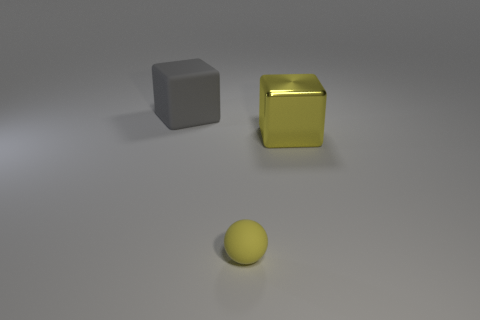How many gray matte objects are in front of the big object on the left side of the big yellow shiny block?
Make the answer very short. 0. Are there any tiny objects that have the same shape as the large gray matte thing?
Your answer should be compact. No. Do the large object in front of the big gray rubber block and the yellow object to the left of the large yellow thing have the same shape?
Make the answer very short. No. What is the shape of the thing that is behind the rubber ball and on the right side of the gray matte block?
Offer a very short reply. Cube. Is there a gray rubber cube that has the same size as the shiny block?
Provide a short and direct response. Yes. Does the sphere have the same color as the rubber thing on the left side of the tiny matte sphere?
Provide a succinct answer. No. What is the small yellow sphere made of?
Make the answer very short. Rubber. There is a rubber object that is in front of the big gray matte thing; what color is it?
Keep it short and to the point. Yellow. What number of tiny objects are the same color as the tiny ball?
Give a very brief answer. 0. How many large blocks are both left of the yellow block and on the right side of the large gray cube?
Keep it short and to the point. 0. 